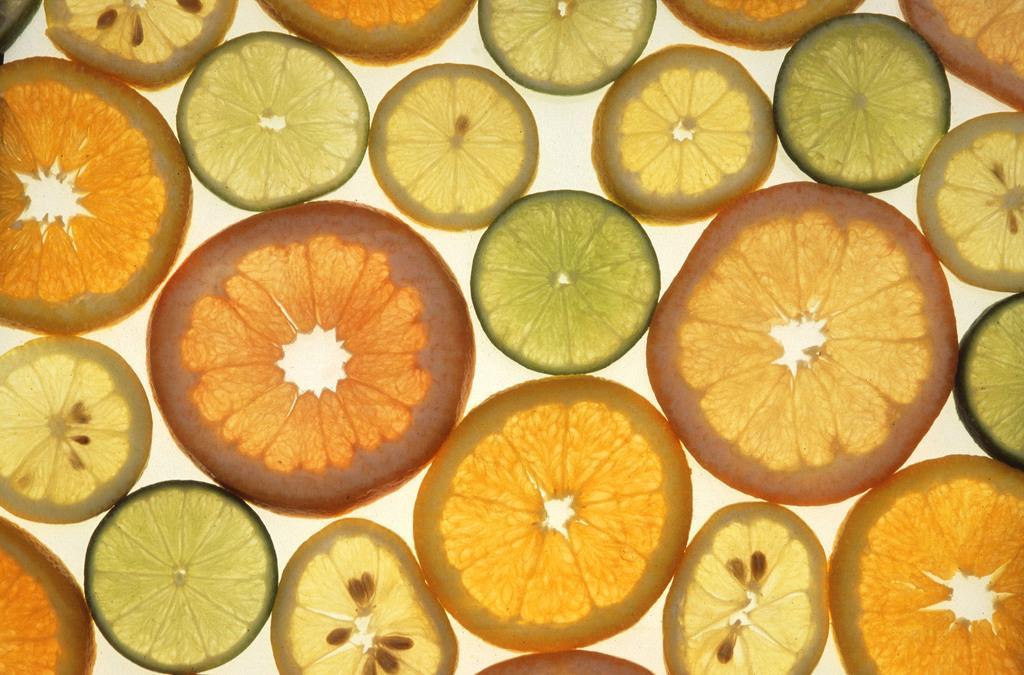Please provide a concise description of this image. In this image I can see few orange and few lemon pieces. They are in orange,green color. Background is in white color. 